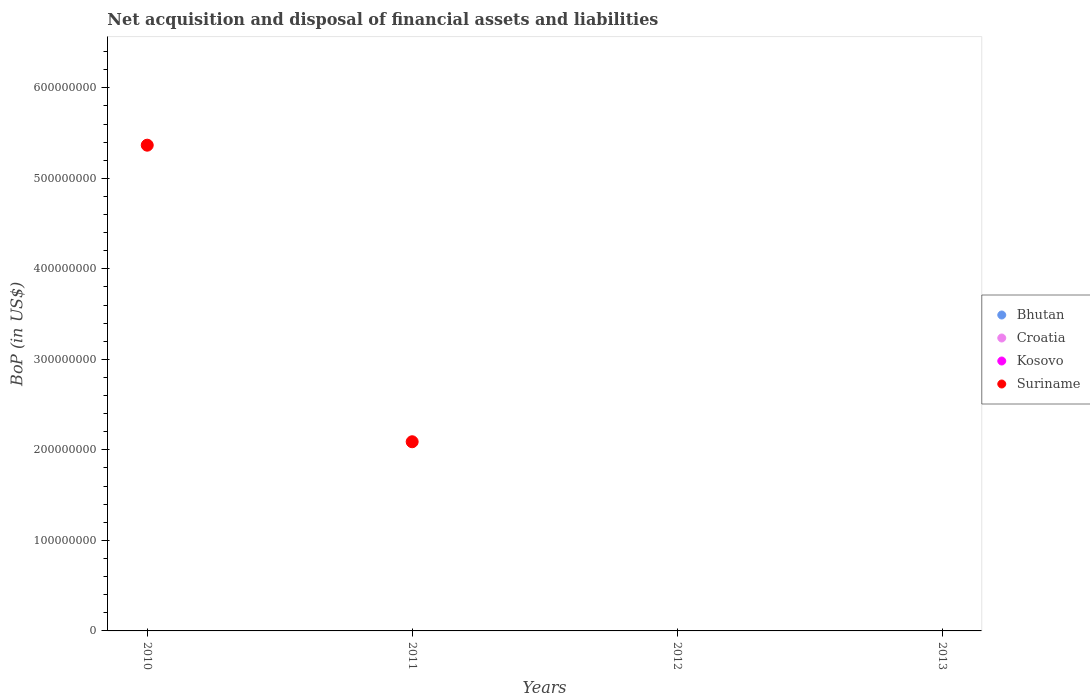How many different coloured dotlines are there?
Keep it short and to the point. 1. Across all years, what is the maximum Balance of Payments in Suriname?
Make the answer very short. 5.37e+08. Across all years, what is the minimum Balance of Payments in Bhutan?
Ensure brevity in your answer.  0. What is the total Balance of Payments in Bhutan in the graph?
Give a very brief answer. 0. What is the difference between the Balance of Payments in Suriname in 2011 and the Balance of Payments in Bhutan in 2010?
Give a very brief answer. 2.09e+08. What is the average Balance of Payments in Kosovo per year?
Provide a succinct answer. 0. What is the difference between the highest and the lowest Balance of Payments in Suriname?
Offer a terse response. 5.37e+08. In how many years, is the Balance of Payments in Bhutan greater than the average Balance of Payments in Bhutan taken over all years?
Your response must be concise. 0. Is it the case that in every year, the sum of the Balance of Payments in Kosovo and Balance of Payments in Bhutan  is greater than the sum of Balance of Payments in Croatia and Balance of Payments in Suriname?
Offer a terse response. No. Does the Balance of Payments in Croatia monotonically increase over the years?
Your answer should be compact. No. Is the Balance of Payments in Suriname strictly less than the Balance of Payments in Kosovo over the years?
Offer a terse response. No. How many dotlines are there?
Your response must be concise. 1. Does the graph contain any zero values?
Your answer should be compact. Yes. Does the graph contain grids?
Your answer should be compact. No. How are the legend labels stacked?
Provide a succinct answer. Vertical. What is the title of the graph?
Make the answer very short. Net acquisition and disposal of financial assets and liabilities. What is the label or title of the Y-axis?
Offer a very short reply. BoP (in US$). What is the BoP (in US$) of Kosovo in 2010?
Offer a terse response. 0. What is the BoP (in US$) of Suriname in 2010?
Offer a terse response. 5.37e+08. What is the BoP (in US$) of Bhutan in 2011?
Your answer should be compact. 0. What is the BoP (in US$) of Croatia in 2011?
Provide a short and direct response. 0. What is the BoP (in US$) of Kosovo in 2011?
Offer a terse response. 0. What is the BoP (in US$) in Suriname in 2011?
Your answer should be very brief. 2.09e+08. What is the BoP (in US$) in Kosovo in 2012?
Your response must be concise. 0. What is the BoP (in US$) in Bhutan in 2013?
Give a very brief answer. 0. Across all years, what is the maximum BoP (in US$) in Suriname?
Provide a short and direct response. 5.37e+08. Across all years, what is the minimum BoP (in US$) of Suriname?
Provide a succinct answer. 0. What is the total BoP (in US$) in Bhutan in the graph?
Keep it short and to the point. 0. What is the total BoP (in US$) of Croatia in the graph?
Ensure brevity in your answer.  0. What is the total BoP (in US$) in Suriname in the graph?
Keep it short and to the point. 7.46e+08. What is the difference between the BoP (in US$) in Suriname in 2010 and that in 2011?
Your response must be concise. 3.28e+08. What is the average BoP (in US$) in Bhutan per year?
Make the answer very short. 0. What is the average BoP (in US$) in Suriname per year?
Offer a terse response. 1.86e+08. What is the ratio of the BoP (in US$) of Suriname in 2010 to that in 2011?
Your answer should be very brief. 2.57. What is the difference between the highest and the lowest BoP (in US$) in Suriname?
Your response must be concise. 5.37e+08. 